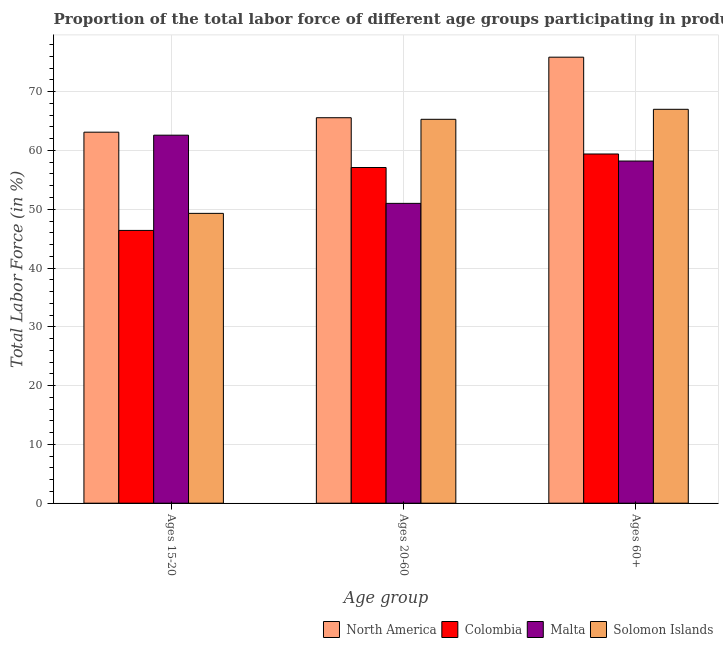How many groups of bars are there?
Offer a very short reply. 3. Are the number of bars per tick equal to the number of legend labels?
Your answer should be compact. Yes. How many bars are there on the 3rd tick from the left?
Provide a short and direct response. 4. What is the label of the 1st group of bars from the left?
Provide a succinct answer. Ages 15-20. What is the percentage of labor force within the age group 15-20 in Malta?
Ensure brevity in your answer.  62.6. Across all countries, what is the maximum percentage of labor force within the age group 20-60?
Give a very brief answer. 65.57. Across all countries, what is the minimum percentage of labor force above age 60?
Provide a short and direct response. 58.2. In which country was the percentage of labor force within the age group 20-60 minimum?
Offer a terse response. Malta. What is the total percentage of labor force within the age group 15-20 in the graph?
Make the answer very short. 221.41. What is the difference between the percentage of labor force within the age group 20-60 in North America and that in Colombia?
Your response must be concise. 8.47. What is the difference between the percentage of labor force within the age group 20-60 in Malta and the percentage of labor force above age 60 in Colombia?
Keep it short and to the point. -8.4. What is the average percentage of labor force above age 60 per country?
Keep it short and to the point. 65.12. What is the difference between the percentage of labor force within the age group 15-20 and percentage of labor force above age 60 in North America?
Keep it short and to the point. -12.76. In how many countries, is the percentage of labor force within the age group 20-60 greater than 10 %?
Provide a short and direct response. 4. What is the ratio of the percentage of labor force within the age group 15-20 in Solomon Islands to that in Malta?
Your answer should be compact. 0.79. Is the difference between the percentage of labor force within the age group 15-20 in Malta and North America greater than the difference between the percentage of labor force above age 60 in Malta and North America?
Provide a succinct answer. Yes. What is the difference between the highest and the second highest percentage of labor force above age 60?
Provide a succinct answer. 8.87. What is the difference between the highest and the lowest percentage of labor force within the age group 20-60?
Make the answer very short. 14.57. In how many countries, is the percentage of labor force within the age group 15-20 greater than the average percentage of labor force within the age group 15-20 taken over all countries?
Give a very brief answer. 2. What does the 3rd bar from the left in Ages 60+ represents?
Offer a terse response. Malta. Are all the bars in the graph horizontal?
Your answer should be compact. No. What is the difference between two consecutive major ticks on the Y-axis?
Make the answer very short. 10. Does the graph contain grids?
Keep it short and to the point. Yes. Where does the legend appear in the graph?
Offer a very short reply. Bottom right. How many legend labels are there?
Provide a succinct answer. 4. How are the legend labels stacked?
Keep it short and to the point. Horizontal. What is the title of the graph?
Your response must be concise. Proportion of the total labor force of different age groups participating in production in 1995. Does "Cyprus" appear as one of the legend labels in the graph?
Offer a very short reply. No. What is the label or title of the X-axis?
Your response must be concise. Age group. What is the label or title of the Y-axis?
Make the answer very short. Total Labor Force (in %). What is the Total Labor Force (in %) of North America in Ages 15-20?
Ensure brevity in your answer.  63.11. What is the Total Labor Force (in %) in Colombia in Ages 15-20?
Give a very brief answer. 46.4. What is the Total Labor Force (in %) in Malta in Ages 15-20?
Ensure brevity in your answer.  62.6. What is the Total Labor Force (in %) of Solomon Islands in Ages 15-20?
Offer a very short reply. 49.3. What is the Total Labor Force (in %) of North America in Ages 20-60?
Provide a short and direct response. 65.57. What is the Total Labor Force (in %) of Colombia in Ages 20-60?
Offer a very short reply. 57.1. What is the Total Labor Force (in %) of Malta in Ages 20-60?
Offer a terse response. 51. What is the Total Labor Force (in %) of Solomon Islands in Ages 20-60?
Make the answer very short. 65.3. What is the Total Labor Force (in %) of North America in Ages 60+?
Give a very brief answer. 75.87. What is the Total Labor Force (in %) of Colombia in Ages 60+?
Provide a succinct answer. 59.4. What is the Total Labor Force (in %) in Malta in Ages 60+?
Ensure brevity in your answer.  58.2. What is the Total Labor Force (in %) of Solomon Islands in Ages 60+?
Keep it short and to the point. 67. Across all Age group, what is the maximum Total Labor Force (in %) in North America?
Offer a very short reply. 75.87. Across all Age group, what is the maximum Total Labor Force (in %) in Colombia?
Make the answer very short. 59.4. Across all Age group, what is the maximum Total Labor Force (in %) in Malta?
Offer a terse response. 62.6. Across all Age group, what is the minimum Total Labor Force (in %) in North America?
Offer a very short reply. 63.11. Across all Age group, what is the minimum Total Labor Force (in %) in Colombia?
Offer a terse response. 46.4. Across all Age group, what is the minimum Total Labor Force (in %) of Malta?
Offer a terse response. 51. Across all Age group, what is the minimum Total Labor Force (in %) in Solomon Islands?
Keep it short and to the point. 49.3. What is the total Total Labor Force (in %) of North America in the graph?
Offer a very short reply. 204.55. What is the total Total Labor Force (in %) of Colombia in the graph?
Your response must be concise. 162.9. What is the total Total Labor Force (in %) in Malta in the graph?
Your answer should be compact. 171.8. What is the total Total Labor Force (in %) of Solomon Islands in the graph?
Ensure brevity in your answer.  181.6. What is the difference between the Total Labor Force (in %) of North America in Ages 15-20 and that in Ages 20-60?
Offer a very short reply. -2.46. What is the difference between the Total Labor Force (in %) in Colombia in Ages 15-20 and that in Ages 20-60?
Keep it short and to the point. -10.7. What is the difference between the Total Labor Force (in %) of North America in Ages 15-20 and that in Ages 60+?
Your response must be concise. -12.76. What is the difference between the Total Labor Force (in %) of Colombia in Ages 15-20 and that in Ages 60+?
Make the answer very short. -13. What is the difference between the Total Labor Force (in %) in Malta in Ages 15-20 and that in Ages 60+?
Provide a succinct answer. 4.4. What is the difference between the Total Labor Force (in %) in Solomon Islands in Ages 15-20 and that in Ages 60+?
Offer a terse response. -17.7. What is the difference between the Total Labor Force (in %) of North America in Ages 20-60 and that in Ages 60+?
Provide a short and direct response. -10.3. What is the difference between the Total Labor Force (in %) of Solomon Islands in Ages 20-60 and that in Ages 60+?
Keep it short and to the point. -1.7. What is the difference between the Total Labor Force (in %) in North America in Ages 15-20 and the Total Labor Force (in %) in Colombia in Ages 20-60?
Offer a terse response. 6.01. What is the difference between the Total Labor Force (in %) in North America in Ages 15-20 and the Total Labor Force (in %) in Malta in Ages 20-60?
Give a very brief answer. 12.11. What is the difference between the Total Labor Force (in %) in North America in Ages 15-20 and the Total Labor Force (in %) in Solomon Islands in Ages 20-60?
Your response must be concise. -2.19. What is the difference between the Total Labor Force (in %) in Colombia in Ages 15-20 and the Total Labor Force (in %) in Malta in Ages 20-60?
Provide a succinct answer. -4.6. What is the difference between the Total Labor Force (in %) of Colombia in Ages 15-20 and the Total Labor Force (in %) of Solomon Islands in Ages 20-60?
Keep it short and to the point. -18.9. What is the difference between the Total Labor Force (in %) of North America in Ages 15-20 and the Total Labor Force (in %) of Colombia in Ages 60+?
Offer a very short reply. 3.71. What is the difference between the Total Labor Force (in %) in North America in Ages 15-20 and the Total Labor Force (in %) in Malta in Ages 60+?
Give a very brief answer. 4.91. What is the difference between the Total Labor Force (in %) of North America in Ages 15-20 and the Total Labor Force (in %) of Solomon Islands in Ages 60+?
Ensure brevity in your answer.  -3.89. What is the difference between the Total Labor Force (in %) of Colombia in Ages 15-20 and the Total Labor Force (in %) of Solomon Islands in Ages 60+?
Offer a very short reply. -20.6. What is the difference between the Total Labor Force (in %) in Malta in Ages 15-20 and the Total Labor Force (in %) in Solomon Islands in Ages 60+?
Give a very brief answer. -4.4. What is the difference between the Total Labor Force (in %) of North America in Ages 20-60 and the Total Labor Force (in %) of Colombia in Ages 60+?
Your answer should be compact. 6.17. What is the difference between the Total Labor Force (in %) in North America in Ages 20-60 and the Total Labor Force (in %) in Malta in Ages 60+?
Your response must be concise. 7.37. What is the difference between the Total Labor Force (in %) in North America in Ages 20-60 and the Total Labor Force (in %) in Solomon Islands in Ages 60+?
Your answer should be very brief. -1.43. What is the difference between the Total Labor Force (in %) of Colombia in Ages 20-60 and the Total Labor Force (in %) of Malta in Ages 60+?
Offer a terse response. -1.1. What is the difference between the Total Labor Force (in %) of Malta in Ages 20-60 and the Total Labor Force (in %) of Solomon Islands in Ages 60+?
Your answer should be compact. -16. What is the average Total Labor Force (in %) of North America per Age group?
Your answer should be very brief. 68.18. What is the average Total Labor Force (in %) of Colombia per Age group?
Provide a short and direct response. 54.3. What is the average Total Labor Force (in %) in Malta per Age group?
Provide a short and direct response. 57.27. What is the average Total Labor Force (in %) of Solomon Islands per Age group?
Ensure brevity in your answer.  60.53. What is the difference between the Total Labor Force (in %) in North America and Total Labor Force (in %) in Colombia in Ages 15-20?
Keep it short and to the point. 16.71. What is the difference between the Total Labor Force (in %) in North America and Total Labor Force (in %) in Malta in Ages 15-20?
Make the answer very short. 0.51. What is the difference between the Total Labor Force (in %) of North America and Total Labor Force (in %) of Solomon Islands in Ages 15-20?
Offer a terse response. 13.81. What is the difference between the Total Labor Force (in %) in Colombia and Total Labor Force (in %) in Malta in Ages 15-20?
Make the answer very short. -16.2. What is the difference between the Total Labor Force (in %) of North America and Total Labor Force (in %) of Colombia in Ages 20-60?
Your response must be concise. 8.47. What is the difference between the Total Labor Force (in %) of North America and Total Labor Force (in %) of Malta in Ages 20-60?
Your response must be concise. 14.57. What is the difference between the Total Labor Force (in %) in North America and Total Labor Force (in %) in Solomon Islands in Ages 20-60?
Your answer should be compact. 0.27. What is the difference between the Total Labor Force (in %) of Colombia and Total Labor Force (in %) of Malta in Ages 20-60?
Provide a short and direct response. 6.1. What is the difference between the Total Labor Force (in %) in Malta and Total Labor Force (in %) in Solomon Islands in Ages 20-60?
Provide a short and direct response. -14.3. What is the difference between the Total Labor Force (in %) of North America and Total Labor Force (in %) of Colombia in Ages 60+?
Offer a terse response. 16.47. What is the difference between the Total Labor Force (in %) of North America and Total Labor Force (in %) of Malta in Ages 60+?
Give a very brief answer. 17.67. What is the difference between the Total Labor Force (in %) in North America and Total Labor Force (in %) in Solomon Islands in Ages 60+?
Offer a terse response. 8.87. What is the difference between the Total Labor Force (in %) of Malta and Total Labor Force (in %) of Solomon Islands in Ages 60+?
Ensure brevity in your answer.  -8.8. What is the ratio of the Total Labor Force (in %) of North America in Ages 15-20 to that in Ages 20-60?
Provide a short and direct response. 0.96. What is the ratio of the Total Labor Force (in %) of Colombia in Ages 15-20 to that in Ages 20-60?
Make the answer very short. 0.81. What is the ratio of the Total Labor Force (in %) in Malta in Ages 15-20 to that in Ages 20-60?
Your answer should be compact. 1.23. What is the ratio of the Total Labor Force (in %) in Solomon Islands in Ages 15-20 to that in Ages 20-60?
Your answer should be compact. 0.76. What is the ratio of the Total Labor Force (in %) of North America in Ages 15-20 to that in Ages 60+?
Make the answer very short. 0.83. What is the ratio of the Total Labor Force (in %) in Colombia in Ages 15-20 to that in Ages 60+?
Your answer should be very brief. 0.78. What is the ratio of the Total Labor Force (in %) of Malta in Ages 15-20 to that in Ages 60+?
Your answer should be compact. 1.08. What is the ratio of the Total Labor Force (in %) of Solomon Islands in Ages 15-20 to that in Ages 60+?
Your answer should be very brief. 0.74. What is the ratio of the Total Labor Force (in %) of North America in Ages 20-60 to that in Ages 60+?
Provide a short and direct response. 0.86. What is the ratio of the Total Labor Force (in %) of Colombia in Ages 20-60 to that in Ages 60+?
Offer a terse response. 0.96. What is the ratio of the Total Labor Force (in %) of Malta in Ages 20-60 to that in Ages 60+?
Your answer should be compact. 0.88. What is the ratio of the Total Labor Force (in %) of Solomon Islands in Ages 20-60 to that in Ages 60+?
Give a very brief answer. 0.97. What is the difference between the highest and the second highest Total Labor Force (in %) in North America?
Your response must be concise. 10.3. What is the difference between the highest and the second highest Total Labor Force (in %) of Colombia?
Your response must be concise. 2.3. What is the difference between the highest and the lowest Total Labor Force (in %) in North America?
Provide a short and direct response. 12.76. What is the difference between the highest and the lowest Total Labor Force (in %) of Malta?
Make the answer very short. 11.6. 